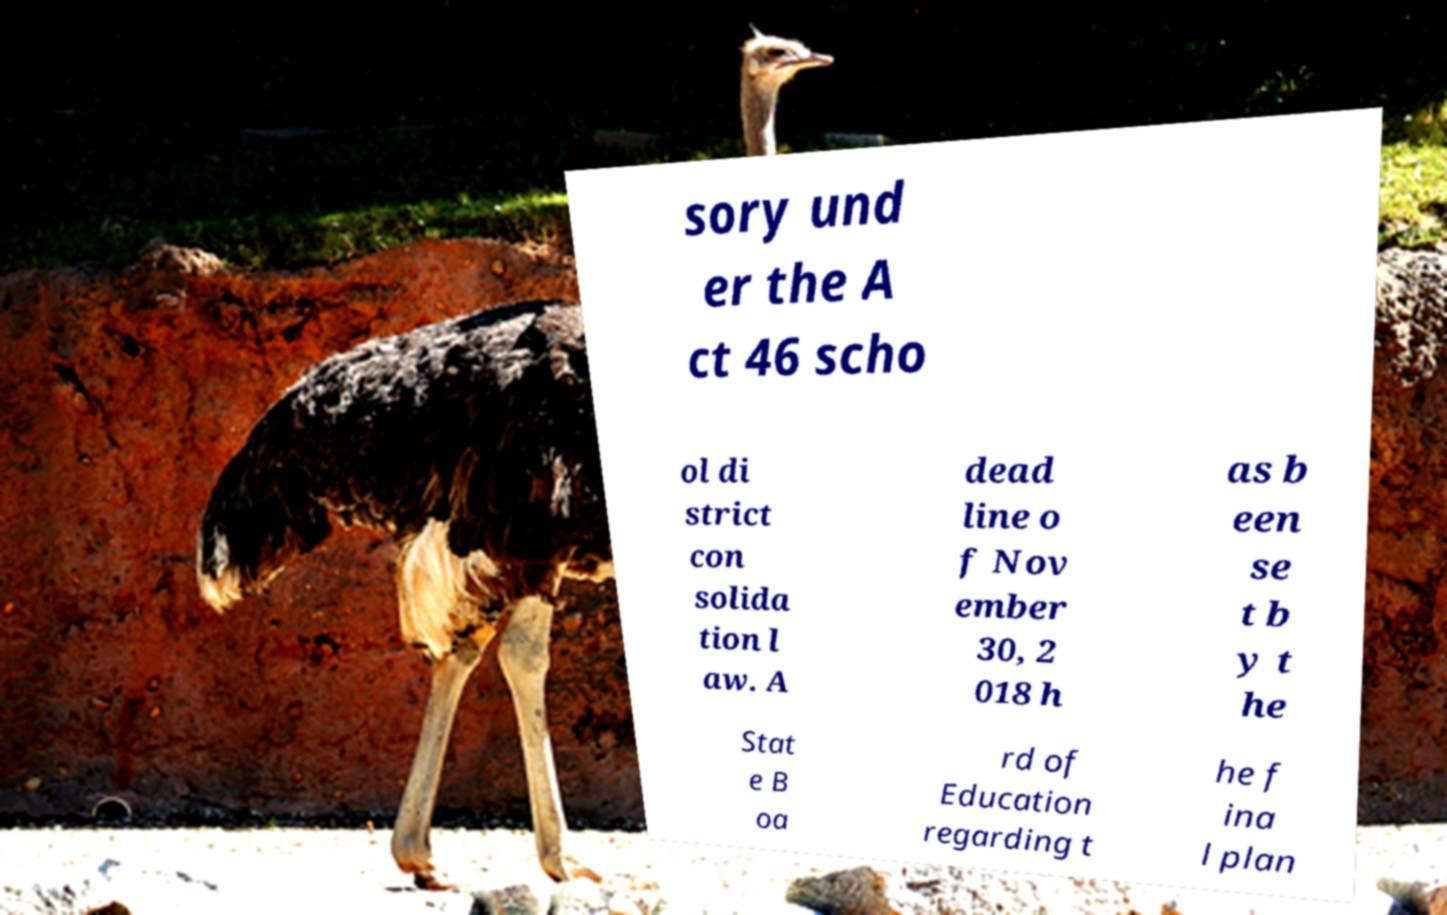Can you accurately transcribe the text from the provided image for me? sory und er the A ct 46 scho ol di strict con solida tion l aw. A dead line o f Nov ember 30, 2 018 h as b een se t b y t he Stat e B oa rd of Education regarding t he f ina l plan 